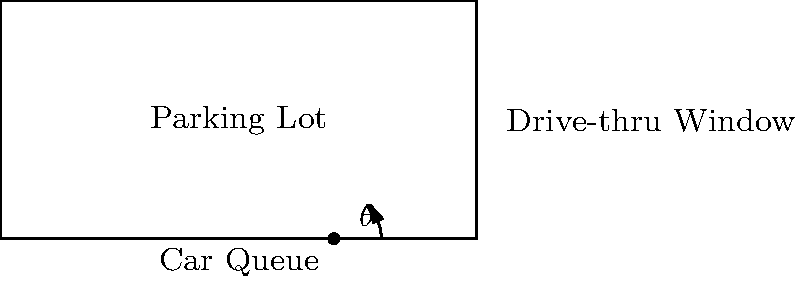Given a rectangular parking lot with dimensions 10 units by 5 units, and a drive-thru window located at the midpoint of the right side, what is the optimal angle $\theta$ for the drive-thru window that maximizes the car queue length within the parking lot? Assume cars line up in a straight line from the window. To solve this problem, we'll follow these steps:

1) The goal is to maximize the length of the line from the drive-thru window to the opposite side of the parking lot.

2) This line forms the hypotenuse of a right triangle. The drive-thru window is at coordinates (10, 2.5).

3) The maximum length line will touch the corner of the parking lot at (0, 0) or (0, 5).

4) Due to symmetry, we only need to consider the triangle to the bottom corner (0, 0).

5) In this triangle:
   - The base is 10 units (full width of the lot)
   - The height is 2.5 units (half the height of the lot)

6) We can find the optimal angle using the arctangent function:

   $$\theta = \arctan(\frac{\text{opposite}}{\text{adjacent}}) = \arctan(\frac{2.5}{10})$$

7) Calculate:
   $$\theta = \arctan(0.25) \approx 14.04\text{°}$$

8) This angle maximizes the queue length, which would be:

   $$\sqrt{10^2 + 2.5^2} = \sqrt{106.25} \approx 10.31\text{ units}$$
Answer: $14.04\text{°}$ 